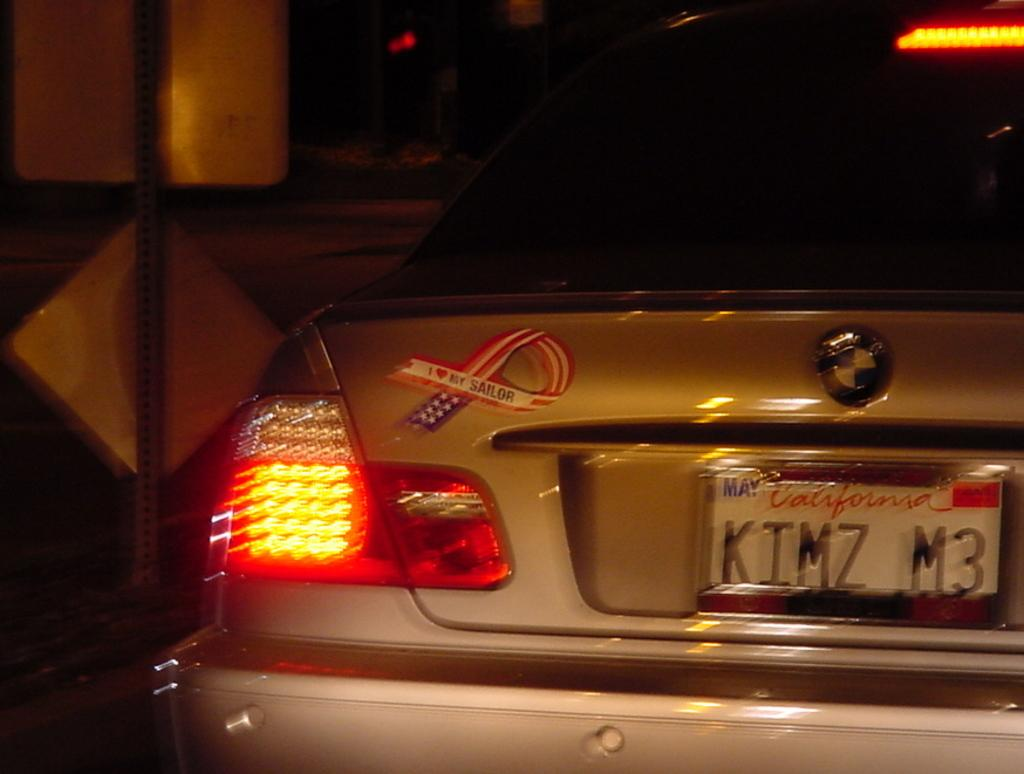<image>
Relay a brief, clear account of the picture shown. The back of a BMW, license plate KIMZ M3 with a "I love my sailor" ribbon magnet near the left taillight. 